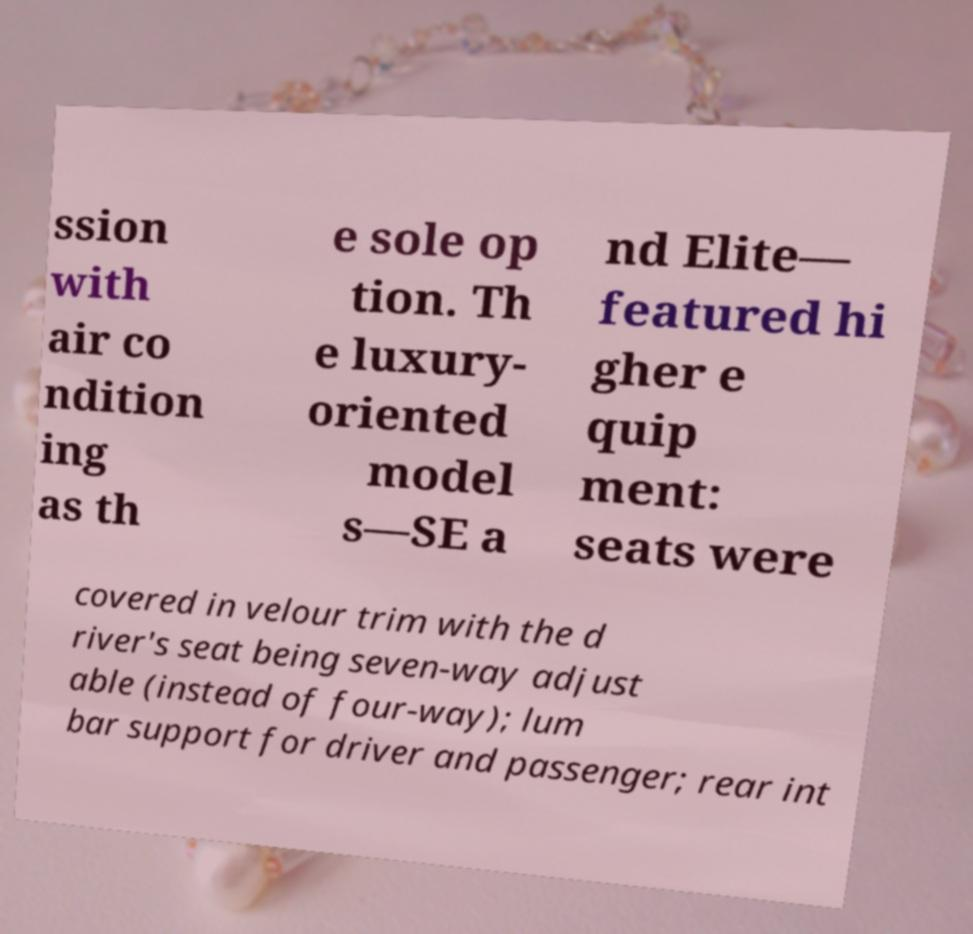Could you extract and type out the text from this image? ssion with air co ndition ing as th e sole op tion. Th e luxury- oriented model s—SE a nd Elite— featured hi gher e quip ment: seats were covered in velour trim with the d river's seat being seven-way adjust able (instead of four-way); lum bar support for driver and passenger; rear int 